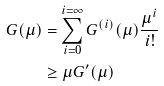Convert formula to latex. <formula><loc_0><loc_0><loc_500><loc_500>G ( \mu ) & = \sum _ { i = 0 } ^ { i = \infty } G ^ { ( i ) } ( \mu ) \frac { \mu ^ { i } } { i ! } \\ & \geq \mu G ^ { \prime } ( \mu )</formula> 